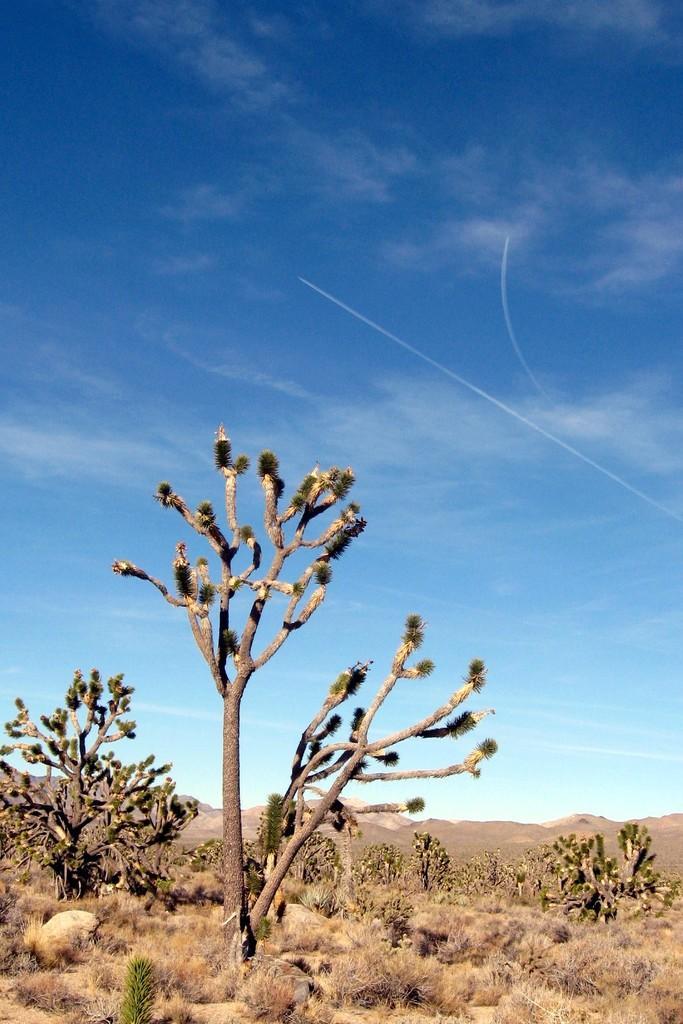Describe this image in one or two sentences. In this image I can see few trees,dry grass,few stones. The sky is in white and blue color. 